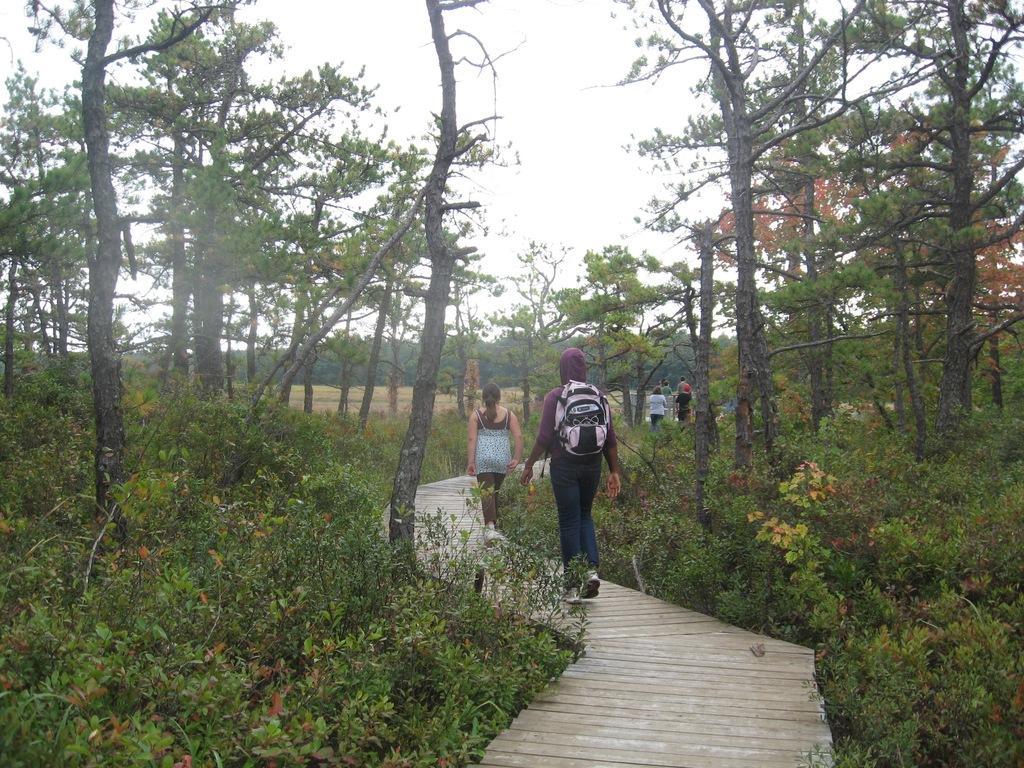Could you give a brief overview of what you see in this image? In this image in the center there are some persons walking on a walkway, on the right side and left side there are some plants and trees. In the background there are trees, at the top of the image there is sky. 